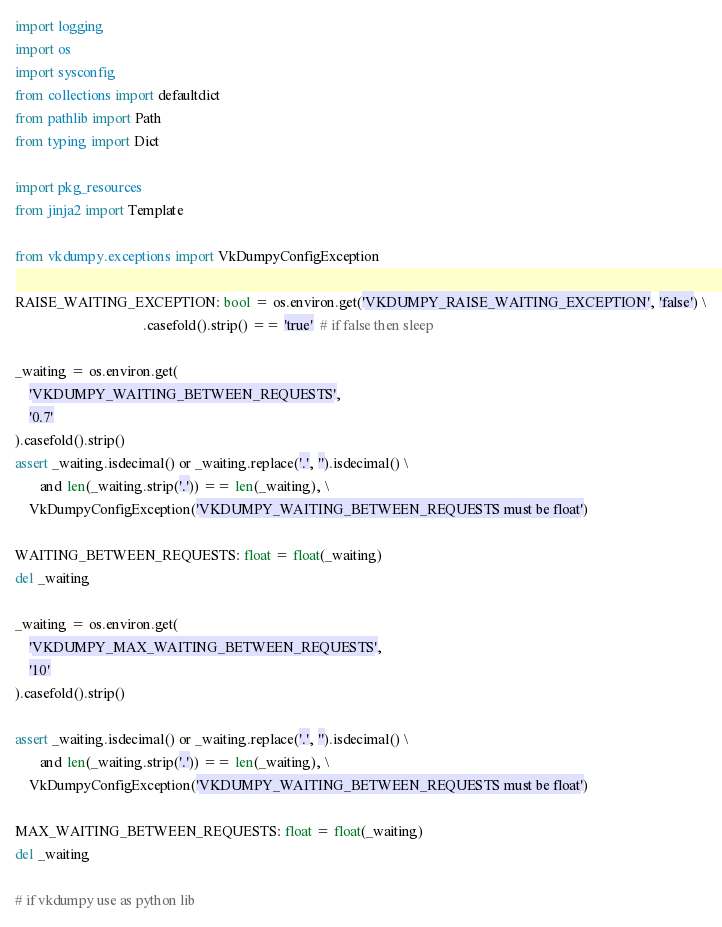<code> <loc_0><loc_0><loc_500><loc_500><_Python_>import logging
import os
import sysconfig
from collections import defaultdict
from pathlib import Path
from typing import Dict

import pkg_resources
from jinja2 import Template

from vkdumpy.exceptions import VkDumpyConfigException

RAISE_WAITING_EXCEPTION: bool = os.environ.get('VKDUMPY_RAISE_WAITING_EXCEPTION', 'false') \
                                    .casefold().strip() == 'true'  # if false then sleep

_waiting = os.environ.get(
    'VKDUMPY_WAITING_BETWEEN_REQUESTS',
    '0.7'
).casefold().strip()
assert _waiting.isdecimal() or _waiting.replace('.', '').isdecimal() \
       and len(_waiting.strip('.')) == len(_waiting), \
    VkDumpyConfigException('VKDUMPY_WAITING_BETWEEN_REQUESTS must be float')

WAITING_BETWEEN_REQUESTS: float = float(_waiting)
del _waiting

_waiting = os.environ.get(
    'VKDUMPY_MAX_WAITING_BETWEEN_REQUESTS',
    '10'
).casefold().strip()

assert _waiting.isdecimal() or _waiting.replace('.', '').isdecimal() \
       and len(_waiting.strip('.')) == len(_waiting), \
    VkDumpyConfigException('VKDUMPY_WAITING_BETWEEN_REQUESTS must be float')

MAX_WAITING_BETWEEN_REQUESTS: float = float(_waiting)
del _waiting

# if vkdumpy use as python lib</code> 